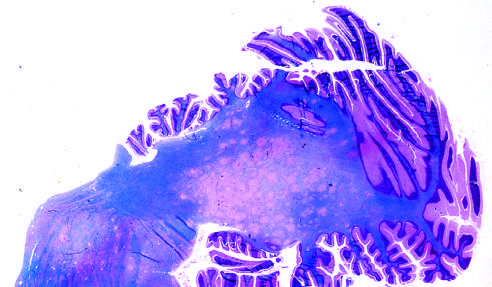what shows irregular, poorly defined areas of demyelination, which become confluent in places?
Answer the question using a single word or phrase. Section stained for myeln 